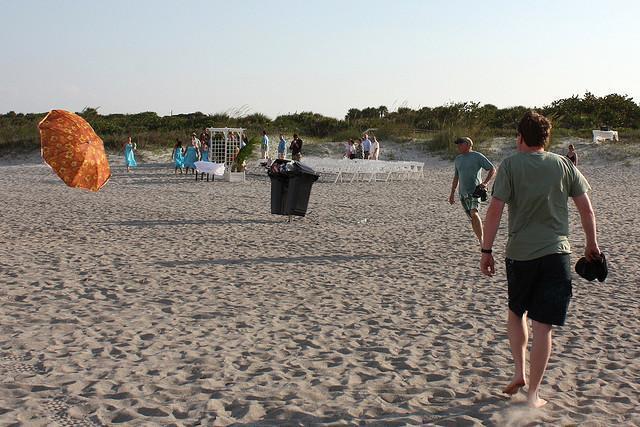How many people are in the picture?
Give a very brief answer. 3. 